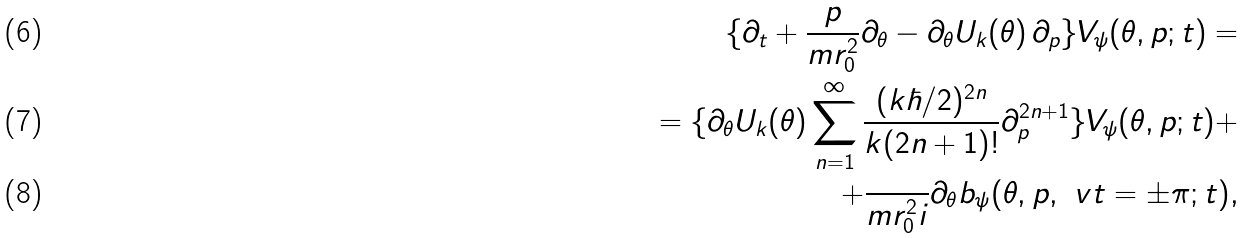<formula> <loc_0><loc_0><loc_500><loc_500>\{ \partial _ { t } + \frac { p } { m r _ { 0 } ^ { 2 } } \partial _ { \theta } - \partial _ { \theta } U _ { k } ( \theta ) \, \partial _ { p } \} V _ { \psi } ( \theta , p ; t ) = \\ = \{ \partial _ { \theta } U _ { k } ( \theta ) \sum _ { n = 1 } ^ { \infty } \frac { ( k \hbar { / } 2 ) ^ { 2 n } } { k ( 2 n + 1 ) ! } \partial _ { p } ^ { 2 n + 1 } \} V _ { \psi } ( \theta , p ; t ) + \\ + \frac { } { m r _ { 0 } ^ { 2 } i } \partial _ { \theta } b _ { \psi } ( \theta , p , \ v t = \pm \pi ; t ) ,</formula> 